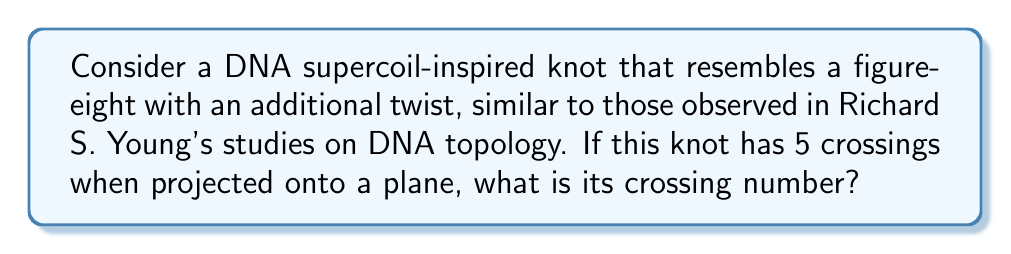Can you answer this question? To determine the crossing number of this DNA supercoil-inspired knot, we need to follow these steps:

1. Understand the concept of crossing number:
   The crossing number of a knot is the minimum number of crossings that occur in any projection of the knot onto a plane.

2. Analyze the given information:
   - The knot resembles a figure-eight with an additional twist.
   - When projected onto a plane, it has 5 crossings.

3. Consider the figure-eight knot:
   - The standard figure-eight knot has a crossing number of 4.
   - This is represented mathematically as:
     $$c(4_1) = 4$$
   Where $4_1$ is the Alexander-Briggs notation for the figure-eight knot.

4. Evaluate the additional twist:
   - The extra twist adds at least one more crossing to the figure-eight knot.
   - This matches the given information of 5 crossings in the projection.

5. Determine if this is the minimal crossing number:
   - Since we cannot reduce the number of crossings further without changing the knot type, 5 is indeed the minimal crossing number.

6. Conclude:
   The crossing number of this DNA supercoil-inspired knot is 5.

This analysis aligns with the topological complexities often observed in DNA supercoils, which Richard S. Young might have encountered in his biological research.
Answer: 5 